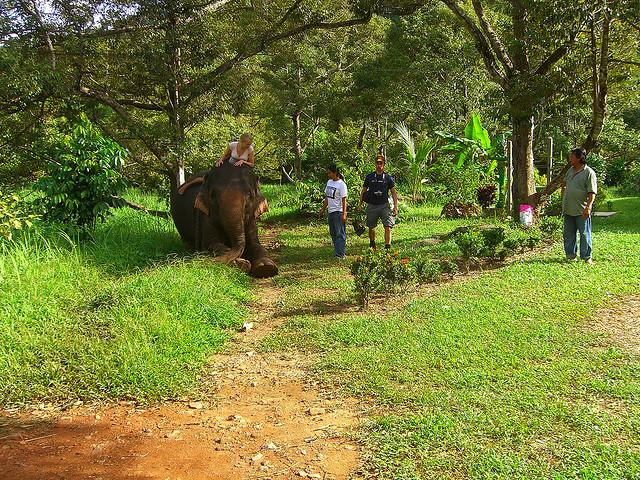Why is the elephant laying down on the left with the tourist on top? Please explain your reasoning. tired. The elephant is very tired. 